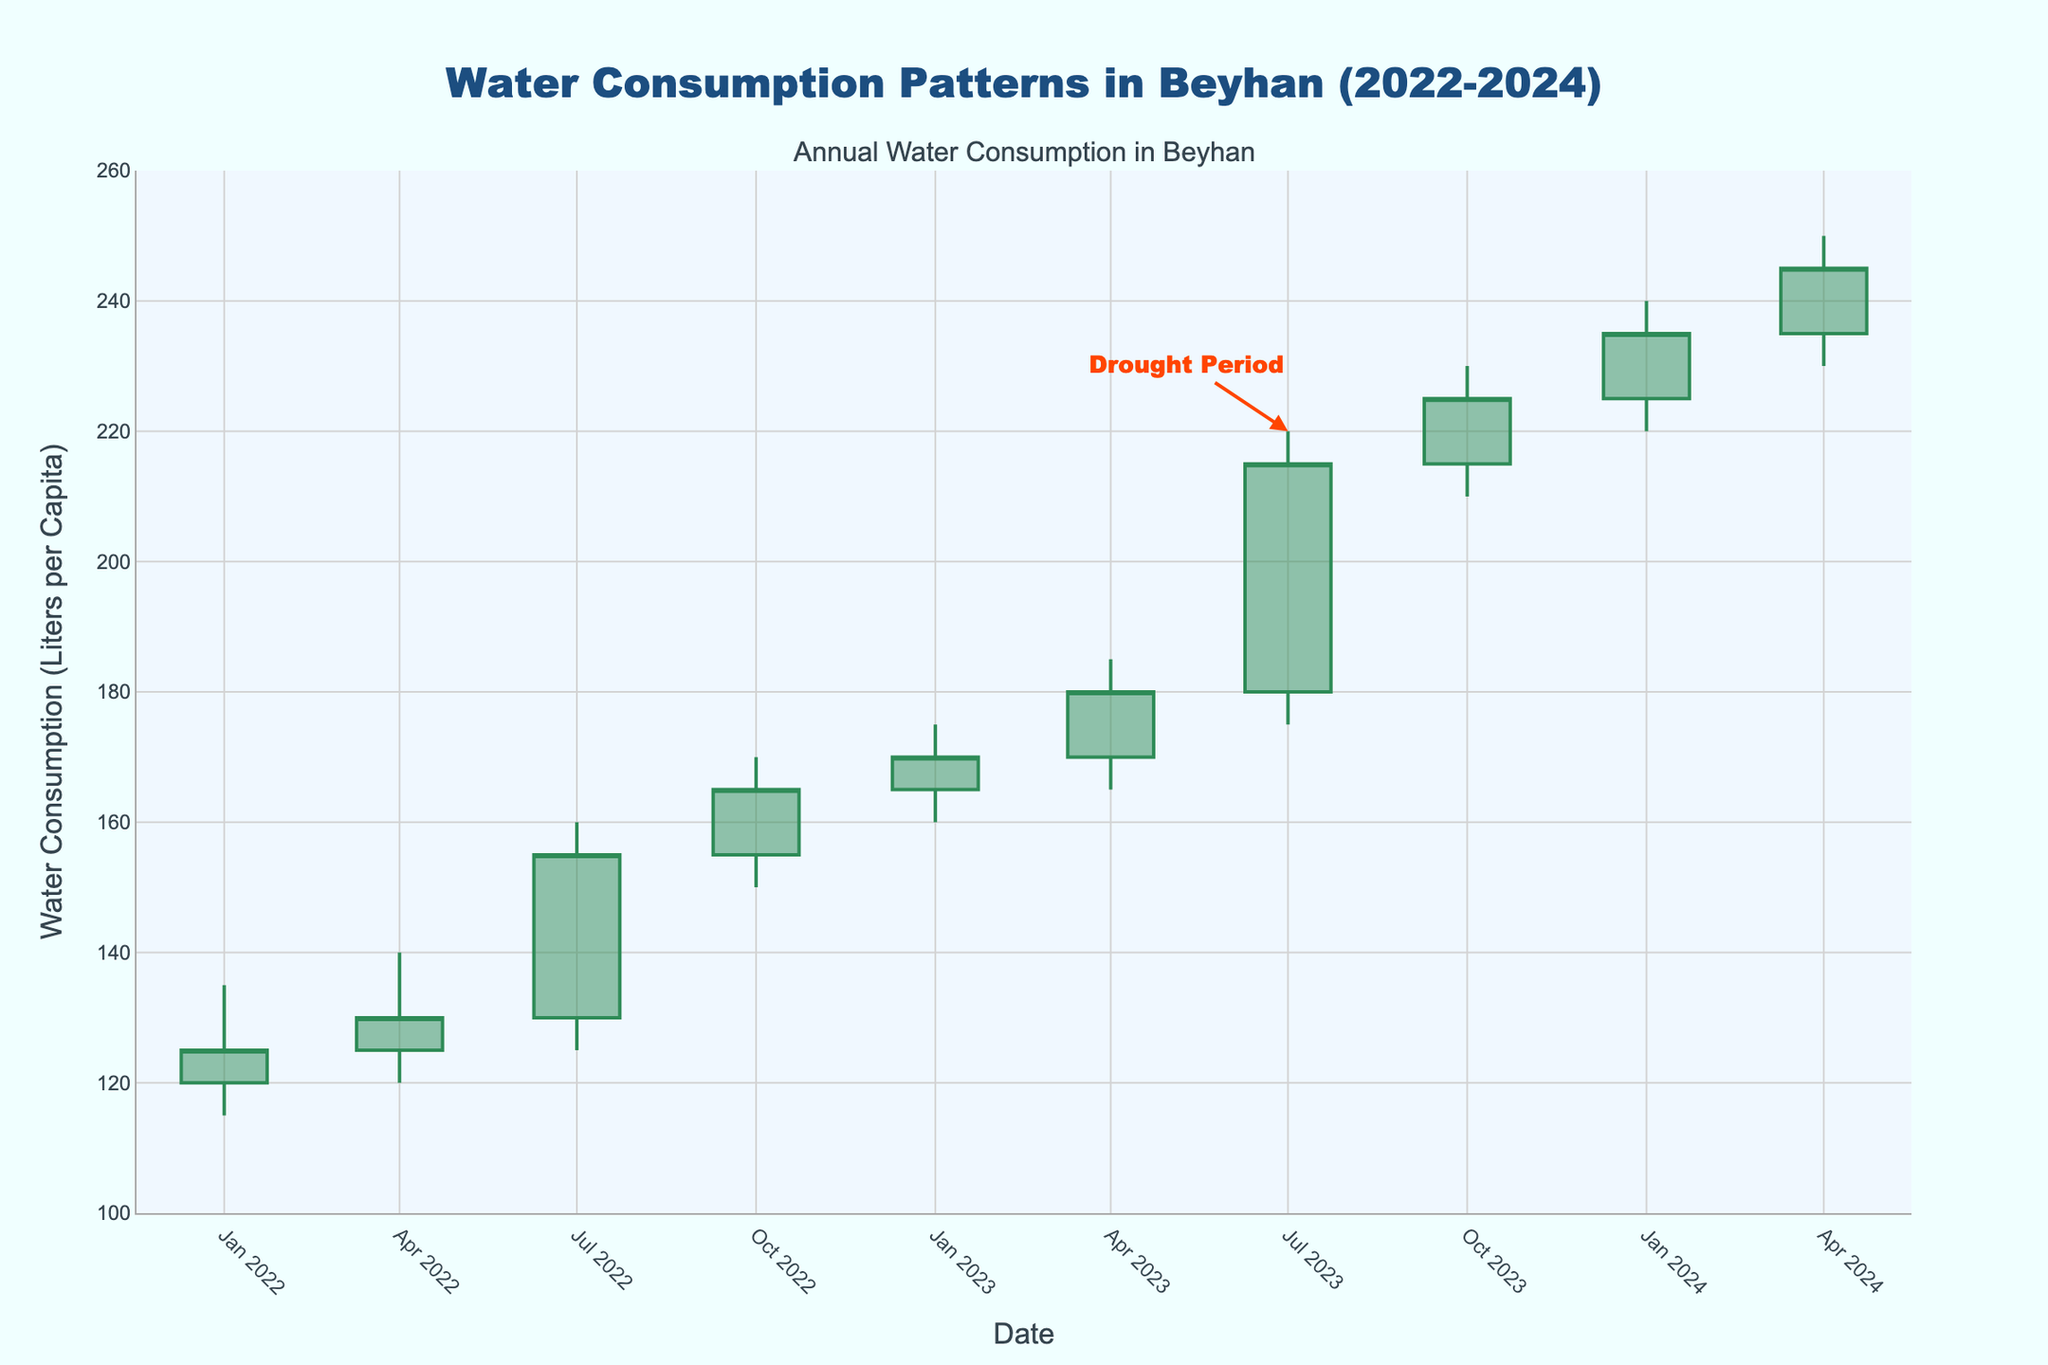What is the title of the chart? The title is displayed at the top center of the chart, which reads "Water Consumption Patterns in Beyhan (2022-2024)."
Answer: Water Consumption Patterns in Beyhan (2022-2024) What does the annotation at '2023-07-01' indicate? The annotation positioned at '2023-07-01' mentions "Drought Period" with an arrow pointing to this time frame, highlighting a significant event.
Answer: Drought Period How many data points are shown on the chart? There are three years worth of quarterly data (Q1, Q2, Q3, Q4) for each year from 2022 to 2024, resulting in a total of 10 data points.
Answer: 10 Which date shows the highest closing value? By examining the "Close" values for each date, the highest closing value is 245 on '2024-04-01'.
Answer: 2024-04-01 Compare the water consumption on '2023-07-01' and '2023-10-01'. Which was higher and by how much? The 'Close' value on '2023-07-01' was 215, and on '2023-10-01' it was 225. 225 - 215 equals 10, so '2023-10-01' was higher by 10.
Answer: '2023-10-01' by 10 What were the opening and closing values during the drought period? The drought period annotation is placed at '2023-07-01.' The 'Open' value on that date was 180, and the 'Close' value was 215.
Answer: Open: 180, Close: 215 Which quarter had the lowest low water consumption in 2022? Examining the 'Low' values for each quarter in 2022, the lowest was 115 on '2022-01-01'.
Answer: 2022-01-01 What was the average closing value for the year 2023? The closing values for 2023 are 170 (January), 180 (April), 215 (July), and 225 (October). Their sum is 170 + 180 + 215 + 225 = 790. There are 4 quarters, so the average is 790 / 4 = 197.5.
Answer: 197.5 What was the range of water consumption in the third quarter of 2023? In '2023-07-01', the 'High' value is 220 and the 'Low' value is 175. The range is 220 - 175 = 45.
Answer: 45 During which period did Beyhan experience a steady increase in closing values without any decrease? Reviewing the closing values over the periods, the values show a consistent upward trend from '2022-07-01' (155) to '2024-04-01' (245) without any decrease in between the periods.
Answer: '2022-07-01' to '2024-04-01' 